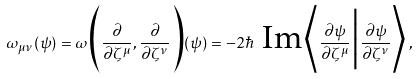Convert formula to latex. <formula><loc_0><loc_0><loc_500><loc_500>\omega _ { \mu \nu } ( \psi ) = \omega \Big ( \frac { \partial } { \partial \zeta ^ { \mu } } , \frac { \partial } { \partial \zeta ^ { \nu } } \Big ) ( \psi ) = - 2 \hbar { \ } \text {Im} \Big \langle \frac { \partial \psi } { \partial \zeta ^ { \mu } } \Big | \frac { \partial \psi } { \partial \zeta ^ { \nu } } \Big \rangle \, ,</formula> 